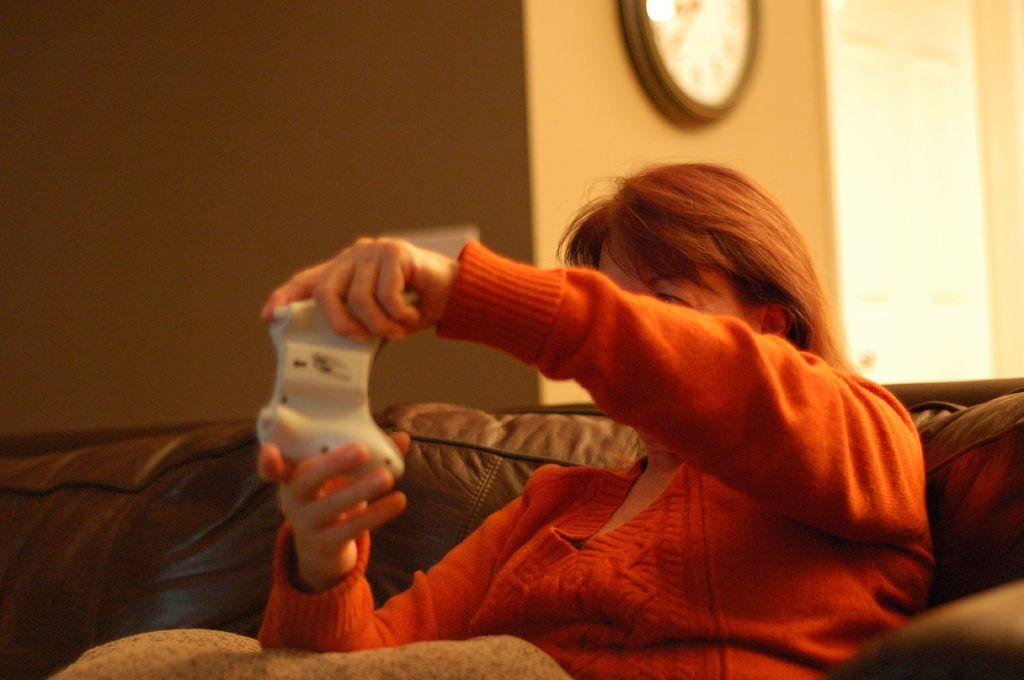What is one of the main features in the image? There is a wall in the image. What object can be seen on the wall? There is a clock in the image. Who is present in the image? There is a woman in the image. What is the woman wearing? The woman is wearing a red dress. What is the woman doing in the image? The woman is sitting on a sofa. What type of leather material is used to make the rake in the image? There is no rake present in the image, so it is not possible to determine the type of leather material used. 